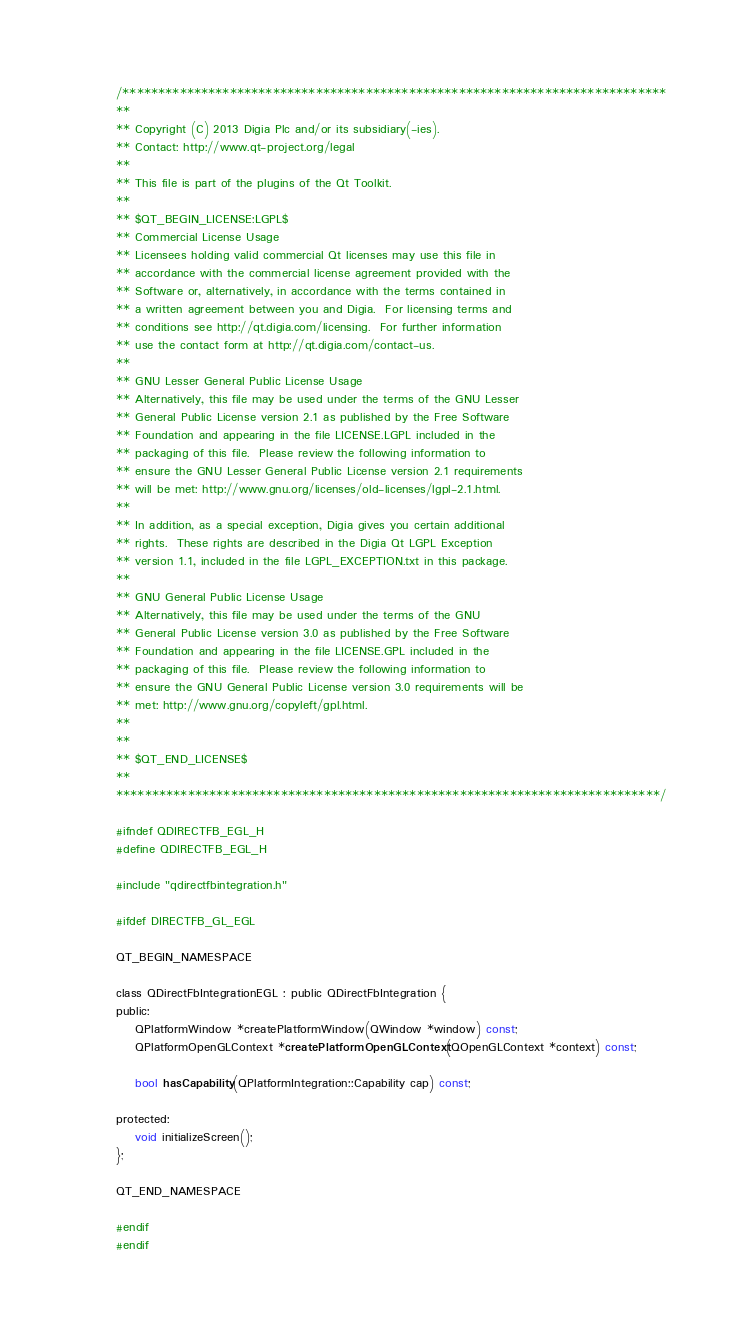<code> <loc_0><loc_0><loc_500><loc_500><_C_>/****************************************************************************
**
** Copyright (C) 2013 Digia Plc and/or its subsidiary(-ies).
** Contact: http://www.qt-project.org/legal
**
** This file is part of the plugins of the Qt Toolkit.
**
** $QT_BEGIN_LICENSE:LGPL$
** Commercial License Usage
** Licensees holding valid commercial Qt licenses may use this file in
** accordance with the commercial license agreement provided with the
** Software or, alternatively, in accordance with the terms contained in
** a written agreement between you and Digia.  For licensing terms and
** conditions see http://qt.digia.com/licensing.  For further information
** use the contact form at http://qt.digia.com/contact-us.
**
** GNU Lesser General Public License Usage
** Alternatively, this file may be used under the terms of the GNU Lesser
** General Public License version 2.1 as published by the Free Software
** Foundation and appearing in the file LICENSE.LGPL included in the
** packaging of this file.  Please review the following information to
** ensure the GNU Lesser General Public License version 2.1 requirements
** will be met: http://www.gnu.org/licenses/old-licenses/lgpl-2.1.html.
**
** In addition, as a special exception, Digia gives you certain additional
** rights.  These rights are described in the Digia Qt LGPL Exception
** version 1.1, included in the file LGPL_EXCEPTION.txt in this package.
**
** GNU General Public License Usage
** Alternatively, this file may be used under the terms of the GNU
** General Public License version 3.0 as published by the Free Software
** Foundation and appearing in the file LICENSE.GPL included in the
** packaging of this file.  Please review the following information to
** ensure the GNU General Public License version 3.0 requirements will be
** met: http://www.gnu.org/copyleft/gpl.html.
**
**
** $QT_END_LICENSE$
**
****************************************************************************/

#ifndef QDIRECTFB_EGL_H
#define QDIRECTFB_EGL_H

#include "qdirectfbintegration.h"

#ifdef DIRECTFB_GL_EGL

QT_BEGIN_NAMESPACE

class QDirectFbIntegrationEGL : public QDirectFbIntegration {
public:
    QPlatformWindow *createPlatformWindow(QWindow *window) const;
    QPlatformOpenGLContext *createPlatformOpenGLContext(QOpenGLContext *context) const;

    bool hasCapability(QPlatformIntegration::Capability cap) const;

protected:
    void initializeScreen();
};

QT_END_NAMESPACE

#endif
#endif
</code> 